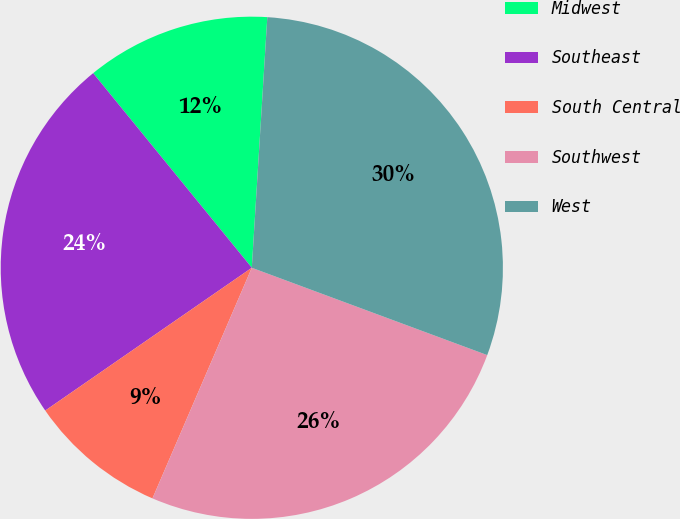Convert chart to OTSL. <chart><loc_0><loc_0><loc_500><loc_500><pie_chart><fcel>Midwest<fcel>Southeast<fcel>South Central<fcel>Southwest<fcel>West<nl><fcel>11.87%<fcel>23.74%<fcel>8.9%<fcel>25.82%<fcel>29.67%<nl></chart> 